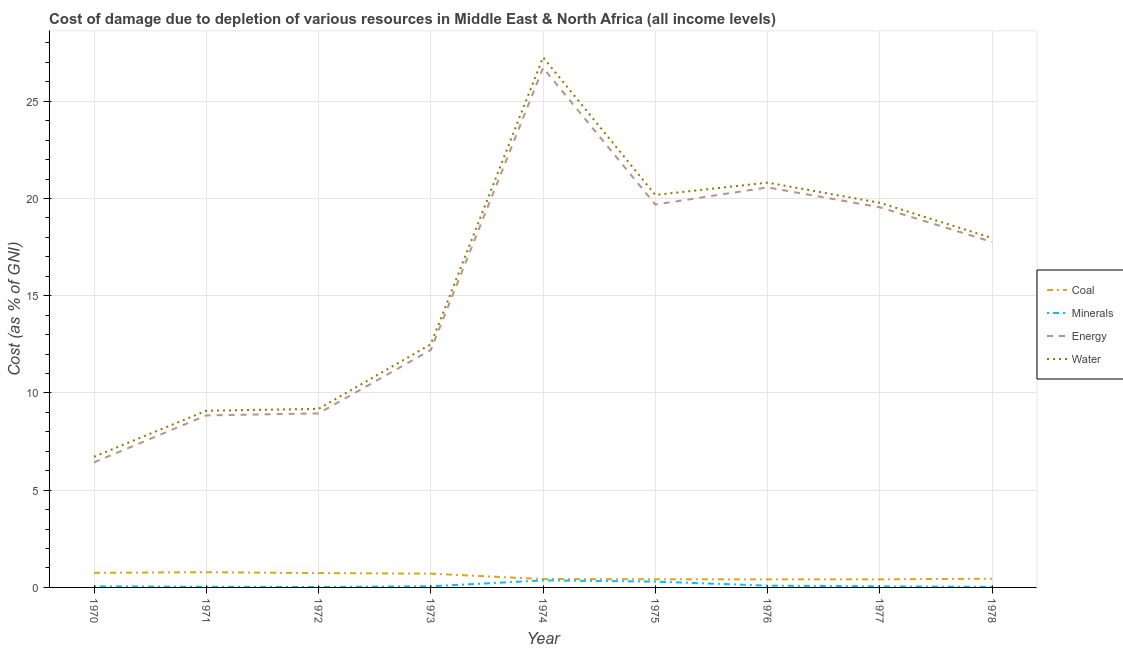Does the line corresponding to cost of damage due to depletion of energy intersect with the line corresponding to cost of damage due to depletion of water?
Make the answer very short. No. Is the number of lines equal to the number of legend labels?
Keep it short and to the point. Yes. What is the cost of damage due to depletion of water in 1973?
Offer a terse response. 12.5. Across all years, what is the maximum cost of damage due to depletion of energy?
Ensure brevity in your answer.  26.72. Across all years, what is the minimum cost of damage due to depletion of energy?
Give a very brief answer. 6.43. In which year was the cost of damage due to depletion of energy maximum?
Your answer should be very brief. 1974. What is the total cost of damage due to depletion of energy in the graph?
Make the answer very short. 140.73. What is the difference between the cost of damage due to depletion of coal in 1975 and that in 1976?
Provide a short and direct response. 0.01. What is the difference between the cost of damage due to depletion of energy in 1978 and the cost of damage due to depletion of coal in 1970?
Your answer should be compact. 17.01. What is the average cost of damage due to depletion of energy per year?
Offer a terse response. 15.64. In the year 1976, what is the difference between the cost of damage due to depletion of coal and cost of damage due to depletion of energy?
Provide a succinct answer. -20.16. In how many years, is the cost of damage due to depletion of minerals greater than 7 %?
Provide a short and direct response. 0. What is the ratio of the cost of damage due to depletion of water in 1974 to that in 1978?
Keep it short and to the point. 1.52. Is the difference between the cost of damage due to depletion of energy in 1971 and 1975 greater than the difference between the cost of damage due to depletion of minerals in 1971 and 1975?
Make the answer very short. No. What is the difference between the highest and the second highest cost of damage due to depletion of water?
Your answer should be compact. 6.45. What is the difference between the highest and the lowest cost of damage due to depletion of coal?
Provide a succinct answer. 0.37. In how many years, is the cost of damage due to depletion of minerals greater than the average cost of damage due to depletion of minerals taken over all years?
Provide a succinct answer. 2. Is it the case that in every year, the sum of the cost of damage due to depletion of coal and cost of damage due to depletion of minerals is greater than the cost of damage due to depletion of energy?
Keep it short and to the point. No. Is the cost of damage due to depletion of coal strictly greater than the cost of damage due to depletion of water over the years?
Provide a short and direct response. No. How many lines are there?
Provide a succinct answer. 4. What is the difference between two consecutive major ticks on the Y-axis?
Your answer should be very brief. 5. Are the values on the major ticks of Y-axis written in scientific E-notation?
Offer a very short reply. No. Does the graph contain any zero values?
Keep it short and to the point. No. How are the legend labels stacked?
Offer a very short reply. Vertical. What is the title of the graph?
Give a very brief answer. Cost of damage due to depletion of various resources in Middle East & North Africa (all income levels) . What is the label or title of the Y-axis?
Give a very brief answer. Cost (as % of GNI). What is the Cost (as % of GNI) in Coal in 1970?
Ensure brevity in your answer.  0.75. What is the Cost (as % of GNI) of Minerals in 1970?
Give a very brief answer. 0.05. What is the Cost (as % of GNI) of Energy in 1970?
Ensure brevity in your answer.  6.43. What is the Cost (as % of GNI) in Water in 1970?
Make the answer very short. 6.72. What is the Cost (as % of GNI) of Coal in 1971?
Make the answer very short. 0.78. What is the Cost (as % of GNI) in Minerals in 1971?
Give a very brief answer. 0.03. What is the Cost (as % of GNI) in Energy in 1971?
Ensure brevity in your answer.  8.85. What is the Cost (as % of GNI) of Water in 1971?
Your answer should be very brief. 9.09. What is the Cost (as % of GNI) in Coal in 1972?
Offer a very short reply. 0.74. What is the Cost (as % of GNI) in Minerals in 1972?
Provide a succinct answer. 0.02. What is the Cost (as % of GNI) of Energy in 1972?
Give a very brief answer. 8.95. What is the Cost (as % of GNI) in Water in 1972?
Keep it short and to the point. 9.18. What is the Cost (as % of GNI) of Coal in 1973?
Offer a very short reply. 0.71. What is the Cost (as % of GNI) in Minerals in 1973?
Provide a short and direct response. 0.06. What is the Cost (as % of GNI) of Energy in 1973?
Your answer should be very brief. 12.21. What is the Cost (as % of GNI) of Water in 1973?
Your answer should be very brief. 12.5. What is the Cost (as % of GNI) of Coal in 1974?
Provide a succinct answer. 0.43. What is the Cost (as % of GNI) of Minerals in 1974?
Offer a terse response. 0.36. What is the Cost (as % of GNI) in Energy in 1974?
Give a very brief answer. 26.72. What is the Cost (as % of GNI) in Water in 1974?
Make the answer very short. 27.26. What is the Cost (as % of GNI) in Coal in 1975?
Offer a terse response. 0.42. What is the Cost (as % of GNI) of Minerals in 1975?
Offer a very short reply. 0.3. What is the Cost (as % of GNI) in Energy in 1975?
Your response must be concise. 19.69. What is the Cost (as % of GNI) of Water in 1975?
Make the answer very short. 20.18. What is the Cost (as % of GNI) of Coal in 1976?
Ensure brevity in your answer.  0.41. What is the Cost (as % of GNI) in Minerals in 1976?
Your response must be concise. 0.09. What is the Cost (as % of GNI) in Energy in 1976?
Your answer should be very brief. 20.57. What is the Cost (as % of GNI) of Water in 1976?
Ensure brevity in your answer.  20.81. What is the Cost (as % of GNI) of Coal in 1977?
Your answer should be very brief. 0.42. What is the Cost (as % of GNI) in Minerals in 1977?
Give a very brief answer. 0.05. What is the Cost (as % of GNI) of Energy in 1977?
Offer a very short reply. 19.55. What is the Cost (as % of GNI) in Water in 1977?
Your response must be concise. 19.78. What is the Cost (as % of GNI) of Coal in 1978?
Make the answer very short. 0.45. What is the Cost (as % of GNI) in Minerals in 1978?
Give a very brief answer. 0.03. What is the Cost (as % of GNI) of Energy in 1978?
Your answer should be very brief. 17.77. What is the Cost (as % of GNI) of Water in 1978?
Give a very brief answer. 17.96. Across all years, what is the maximum Cost (as % of GNI) in Coal?
Offer a terse response. 0.78. Across all years, what is the maximum Cost (as % of GNI) in Minerals?
Your answer should be compact. 0.36. Across all years, what is the maximum Cost (as % of GNI) in Energy?
Offer a very short reply. 26.72. Across all years, what is the maximum Cost (as % of GNI) of Water?
Your answer should be compact. 27.26. Across all years, what is the minimum Cost (as % of GNI) in Coal?
Ensure brevity in your answer.  0.41. Across all years, what is the minimum Cost (as % of GNI) in Minerals?
Keep it short and to the point. 0.02. Across all years, what is the minimum Cost (as % of GNI) in Energy?
Provide a succinct answer. 6.43. Across all years, what is the minimum Cost (as % of GNI) in Water?
Offer a terse response. 6.72. What is the total Cost (as % of GNI) of Coal in the graph?
Ensure brevity in your answer.  5.11. What is the total Cost (as % of GNI) of Minerals in the graph?
Provide a short and direct response. 1.01. What is the total Cost (as % of GNI) in Energy in the graph?
Your response must be concise. 140.73. What is the total Cost (as % of GNI) of Water in the graph?
Give a very brief answer. 143.49. What is the difference between the Cost (as % of GNI) in Coal in 1970 and that in 1971?
Provide a succinct answer. -0.03. What is the difference between the Cost (as % of GNI) in Minerals in 1970 and that in 1971?
Keep it short and to the point. 0.02. What is the difference between the Cost (as % of GNI) of Energy in 1970 and that in 1971?
Your answer should be very brief. -2.41. What is the difference between the Cost (as % of GNI) in Water in 1970 and that in 1971?
Provide a short and direct response. -2.37. What is the difference between the Cost (as % of GNI) of Coal in 1970 and that in 1972?
Make the answer very short. 0.01. What is the difference between the Cost (as % of GNI) of Minerals in 1970 and that in 1972?
Keep it short and to the point. 0.03. What is the difference between the Cost (as % of GNI) of Energy in 1970 and that in 1972?
Ensure brevity in your answer.  -2.52. What is the difference between the Cost (as % of GNI) in Water in 1970 and that in 1972?
Make the answer very short. -2.46. What is the difference between the Cost (as % of GNI) in Coal in 1970 and that in 1973?
Your answer should be compact. 0.04. What is the difference between the Cost (as % of GNI) in Minerals in 1970 and that in 1973?
Give a very brief answer. -0. What is the difference between the Cost (as % of GNI) in Energy in 1970 and that in 1973?
Make the answer very short. -5.78. What is the difference between the Cost (as % of GNI) of Water in 1970 and that in 1973?
Offer a very short reply. -5.78. What is the difference between the Cost (as % of GNI) in Coal in 1970 and that in 1974?
Offer a very short reply. 0.32. What is the difference between the Cost (as % of GNI) in Minerals in 1970 and that in 1974?
Give a very brief answer. -0.31. What is the difference between the Cost (as % of GNI) of Energy in 1970 and that in 1974?
Provide a short and direct response. -20.29. What is the difference between the Cost (as % of GNI) of Water in 1970 and that in 1974?
Make the answer very short. -20.54. What is the difference between the Cost (as % of GNI) of Coal in 1970 and that in 1975?
Provide a short and direct response. 0.33. What is the difference between the Cost (as % of GNI) of Minerals in 1970 and that in 1975?
Your answer should be very brief. -0.24. What is the difference between the Cost (as % of GNI) of Energy in 1970 and that in 1975?
Provide a succinct answer. -13.26. What is the difference between the Cost (as % of GNI) in Water in 1970 and that in 1975?
Give a very brief answer. -13.46. What is the difference between the Cost (as % of GNI) in Coal in 1970 and that in 1976?
Your response must be concise. 0.34. What is the difference between the Cost (as % of GNI) in Minerals in 1970 and that in 1976?
Your response must be concise. -0.04. What is the difference between the Cost (as % of GNI) of Energy in 1970 and that in 1976?
Your answer should be compact. -14.14. What is the difference between the Cost (as % of GNI) of Water in 1970 and that in 1976?
Provide a short and direct response. -14.09. What is the difference between the Cost (as % of GNI) in Coal in 1970 and that in 1977?
Give a very brief answer. 0.34. What is the difference between the Cost (as % of GNI) of Minerals in 1970 and that in 1977?
Your response must be concise. -0. What is the difference between the Cost (as % of GNI) in Energy in 1970 and that in 1977?
Your response must be concise. -13.12. What is the difference between the Cost (as % of GNI) in Water in 1970 and that in 1977?
Your answer should be very brief. -13.06. What is the difference between the Cost (as % of GNI) in Coal in 1970 and that in 1978?
Make the answer very short. 0.3. What is the difference between the Cost (as % of GNI) of Minerals in 1970 and that in 1978?
Your response must be concise. 0.03. What is the difference between the Cost (as % of GNI) of Energy in 1970 and that in 1978?
Offer a terse response. -11.33. What is the difference between the Cost (as % of GNI) of Water in 1970 and that in 1978?
Your response must be concise. -11.24. What is the difference between the Cost (as % of GNI) in Coal in 1971 and that in 1972?
Your answer should be very brief. 0.04. What is the difference between the Cost (as % of GNI) of Minerals in 1971 and that in 1972?
Provide a short and direct response. 0.01. What is the difference between the Cost (as % of GNI) in Energy in 1971 and that in 1972?
Make the answer very short. -0.1. What is the difference between the Cost (as % of GNI) in Water in 1971 and that in 1972?
Provide a short and direct response. -0.1. What is the difference between the Cost (as % of GNI) of Coal in 1971 and that in 1973?
Offer a terse response. 0.07. What is the difference between the Cost (as % of GNI) in Minerals in 1971 and that in 1973?
Provide a short and direct response. -0.02. What is the difference between the Cost (as % of GNI) of Energy in 1971 and that in 1973?
Make the answer very short. -3.36. What is the difference between the Cost (as % of GNI) of Water in 1971 and that in 1973?
Provide a succinct answer. -3.42. What is the difference between the Cost (as % of GNI) in Coal in 1971 and that in 1974?
Your answer should be very brief. 0.35. What is the difference between the Cost (as % of GNI) in Minerals in 1971 and that in 1974?
Give a very brief answer. -0.33. What is the difference between the Cost (as % of GNI) in Energy in 1971 and that in 1974?
Your response must be concise. -17.87. What is the difference between the Cost (as % of GNI) of Water in 1971 and that in 1974?
Provide a short and direct response. -18.17. What is the difference between the Cost (as % of GNI) in Coal in 1971 and that in 1975?
Ensure brevity in your answer.  0.36. What is the difference between the Cost (as % of GNI) of Minerals in 1971 and that in 1975?
Your answer should be very brief. -0.27. What is the difference between the Cost (as % of GNI) in Energy in 1971 and that in 1975?
Provide a short and direct response. -10.84. What is the difference between the Cost (as % of GNI) of Water in 1971 and that in 1975?
Offer a very short reply. -11.1. What is the difference between the Cost (as % of GNI) in Coal in 1971 and that in 1976?
Offer a terse response. 0.37. What is the difference between the Cost (as % of GNI) in Minerals in 1971 and that in 1976?
Provide a succinct answer. -0.06. What is the difference between the Cost (as % of GNI) of Energy in 1971 and that in 1976?
Ensure brevity in your answer.  -11.72. What is the difference between the Cost (as % of GNI) of Water in 1971 and that in 1976?
Your response must be concise. -11.73. What is the difference between the Cost (as % of GNI) of Coal in 1971 and that in 1977?
Give a very brief answer. 0.37. What is the difference between the Cost (as % of GNI) in Minerals in 1971 and that in 1977?
Offer a very short reply. -0.02. What is the difference between the Cost (as % of GNI) of Energy in 1971 and that in 1977?
Make the answer very short. -10.7. What is the difference between the Cost (as % of GNI) in Water in 1971 and that in 1977?
Ensure brevity in your answer.  -10.69. What is the difference between the Cost (as % of GNI) in Coal in 1971 and that in 1978?
Provide a short and direct response. 0.33. What is the difference between the Cost (as % of GNI) of Minerals in 1971 and that in 1978?
Offer a very short reply. 0. What is the difference between the Cost (as % of GNI) in Energy in 1971 and that in 1978?
Make the answer very short. -8.92. What is the difference between the Cost (as % of GNI) of Water in 1971 and that in 1978?
Offer a very short reply. -8.88. What is the difference between the Cost (as % of GNI) in Coal in 1972 and that in 1973?
Make the answer very short. 0.03. What is the difference between the Cost (as % of GNI) of Minerals in 1972 and that in 1973?
Your answer should be compact. -0.03. What is the difference between the Cost (as % of GNI) of Energy in 1972 and that in 1973?
Provide a short and direct response. -3.26. What is the difference between the Cost (as % of GNI) in Water in 1972 and that in 1973?
Offer a very short reply. -3.32. What is the difference between the Cost (as % of GNI) in Coal in 1972 and that in 1974?
Give a very brief answer. 0.31. What is the difference between the Cost (as % of GNI) in Minerals in 1972 and that in 1974?
Ensure brevity in your answer.  -0.34. What is the difference between the Cost (as % of GNI) in Energy in 1972 and that in 1974?
Keep it short and to the point. -17.77. What is the difference between the Cost (as % of GNI) in Water in 1972 and that in 1974?
Your answer should be very brief. -18.08. What is the difference between the Cost (as % of GNI) in Coal in 1972 and that in 1975?
Your response must be concise. 0.32. What is the difference between the Cost (as % of GNI) of Minerals in 1972 and that in 1975?
Provide a short and direct response. -0.27. What is the difference between the Cost (as % of GNI) in Energy in 1972 and that in 1975?
Ensure brevity in your answer.  -10.74. What is the difference between the Cost (as % of GNI) in Water in 1972 and that in 1975?
Your response must be concise. -11. What is the difference between the Cost (as % of GNI) in Coal in 1972 and that in 1976?
Ensure brevity in your answer.  0.33. What is the difference between the Cost (as % of GNI) in Minerals in 1972 and that in 1976?
Provide a succinct answer. -0.07. What is the difference between the Cost (as % of GNI) in Energy in 1972 and that in 1976?
Offer a terse response. -11.62. What is the difference between the Cost (as % of GNI) of Water in 1972 and that in 1976?
Keep it short and to the point. -11.63. What is the difference between the Cost (as % of GNI) of Coal in 1972 and that in 1977?
Ensure brevity in your answer.  0.32. What is the difference between the Cost (as % of GNI) of Minerals in 1972 and that in 1977?
Provide a short and direct response. -0.03. What is the difference between the Cost (as % of GNI) in Energy in 1972 and that in 1977?
Offer a very short reply. -10.6. What is the difference between the Cost (as % of GNI) of Water in 1972 and that in 1977?
Your answer should be very brief. -10.6. What is the difference between the Cost (as % of GNI) in Coal in 1972 and that in 1978?
Keep it short and to the point. 0.29. What is the difference between the Cost (as % of GNI) of Minerals in 1972 and that in 1978?
Your answer should be compact. -0.01. What is the difference between the Cost (as % of GNI) of Energy in 1972 and that in 1978?
Ensure brevity in your answer.  -8.82. What is the difference between the Cost (as % of GNI) in Water in 1972 and that in 1978?
Provide a succinct answer. -8.78. What is the difference between the Cost (as % of GNI) of Coal in 1973 and that in 1974?
Offer a very short reply. 0.28. What is the difference between the Cost (as % of GNI) of Minerals in 1973 and that in 1974?
Provide a short and direct response. -0.3. What is the difference between the Cost (as % of GNI) in Energy in 1973 and that in 1974?
Provide a succinct answer. -14.51. What is the difference between the Cost (as % of GNI) of Water in 1973 and that in 1974?
Make the answer very short. -14.76. What is the difference between the Cost (as % of GNI) in Coal in 1973 and that in 1975?
Provide a short and direct response. 0.29. What is the difference between the Cost (as % of GNI) in Minerals in 1973 and that in 1975?
Your response must be concise. -0.24. What is the difference between the Cost (as % of GNI) of Energy in 1973 and that in 1975?
Give a very brief answer. -7.48. What is the difference between the Cost (as % of GNI) of Water in 1973 and that in 1975?
Your answer should be compact. -7.68. What is the difference between the Cost (as % of GNI) of Coal in 1973 and that in 1976?
Ensure brevity in your answer.  0.29. What is the difference between the Cost (as % of GNI) in Minerals in 1973 and that in 1976?
Provide a succinct answer. -0.03. What is the difference between the Cost (as % of GNI) in Energy in 1973 and that in 1976?
Ensure brevity in your answer.  -8.36. What is the difference between the Cost (as % of GNI) in Water in 1973 and that in 1976?
Provide a short and direct response. -8.31. What is the difference between the Cost (as % of GNI) of Coal in 1973 and that in 1977?
Ensure brevity in your answer.  0.29. What is the difference between the Cost (as % of GNI) in Minerals in 1973 and that in 1977?
Keep it short and to the point. 0. What is the difference between the Cost (as % of GNI) of Energy in 1973 and that in 1977?
Offer a very short reply. -7.34. What is the difference between the Cost (as % of GNI) in Water in 1973 and that in 1977?
Offer a very short reply. -7.27. What is the difference between the Cost (as % of GNI) in Coal in 1973 and that in 1978?
Give a very brief answer. 0.26. What is the difference between the Cost (as % of GNI) in Minerals in 1973 and that in 1978?
Offer a terse response. 0.03. What is the difference between the Cost (as % of GNI) of Energy in 1973 and that in 1978?
Offer a very short reply. -5.56. What is the difference between the Cost (as % of GNI) of Water in 1973 and that in 1978?
Your response must be concise. -5.46. What is the difference between the Cost (as % of GNI) of Coal in 1974 and that in 1975?
Give a very brief answer. 0.01. What is the difference between the Cost (as % of GNI) in Minerals in 1974 and that in 1975?
Your answer should be very brief. 0.06. What is the difference between the Cost (as % of GNI) in Energy in 1974 and that in 1975?
Your answer should be compact. 7.03. What is the difference between the Cost (as % of GNI) in Water in 1974 and that in 1975?
Ensure brevity in your answer.  7.08. What is the difference between the Cost (as % of GNI) in Coal in 1974 and that in 1976?
Your answer should be very brief. 0.02. What is the difference between the Cost (as % of GNI) in Minerals in 1974 and that in 1976?
Offer a terse response. 0.27. What is the difference between the Cost (as % of GNI) in Energy in 1974 and that in 1976?
Keep it short and to the point. 6.15. What is the difference between the Cost (as % of GNI) in Water in 1974 and that in 1976?
Your answer should be compact. 6.45. What is the difference between the Cost (as % of GNI) in Coal in 1974 and that in 1977?
Give a very brief answer. 0.01. What is the difference between the Cost (as % of GNI) in Minerals in 1974 and that in 1977?
Provide a short and direct response. 0.31. What is the difference between the Cost (as % of GNI) in Energy in 1974 and that in 1977?
Your answer should be very brief. 7.17. What is the difference between the Cost (as % of GNI) of Water in 1974 and that in 1977?
Your answer should be very brief. 7.48. What is the difference between the Cost (as % of GNI) in Coal in 1974 and that in 1978?
Your answer should be compact. -0.02. What is the difference between the Cost (as % of GNI) of Minerals in 1974 and that in 1978?
Your answer should be compact. 0.33. What is the difference between the Cost (as % of GNI) of Energy in 1974 and that in 1978?
Keep it short and to the point. 8.95. What is the difference between the Cost (as % of GNI) of Water in 1974 and that in 1978?
Your answer should be very brief. 9.29. What is the difference between the Cost (as % of GNI) of Coal in 1975 and that in 1976?
Keep it short and to the point. 0.01. What is the difference between the Cost (as % of GNI) in Minerals in 1975 and that in 1976?
Provide a succinct answer. 0.21. What is the difference between the Cost (as % of GNI) in Energy in 1975 and that in 1976?
Offer a terse response. -0.88. What is the difference between the Cost (as % of GNI) of Water in 1975 and that in 1976?
Ensure brevity in your answer.  -0.63. What is the difference between the Cost (as % of GNI) in Coal in 1975 and that in 1977?
Make the answer very short. 0. What is the difference between the Cost (as % of GNI) in Minerals in 1975 and that in 1977?
Your answer should be very brief. 0.24. What is the difference between the Cost (as % of GNI) of Energy in 1975 and that in 1977?
Provide a succinct answer. 0.14. What is the difference between the Cost (as % of GNI) in Water in 1975 and that in 1977?
Your answer should be compact. 0.4. What is the difference between the Cost (as % of GNI) of Coal in 1975 and that in 1978?
Offer a terse response. -0.03. What is the difference between the Cost (as % of GNI) in Minerals in 1975 and that in 1978?
Ensure brevity in your answer.  0.27. What is the difference between the Cost (as % of GNI) in Energy in 1975 and that in 1978?
Your answer should be compact. 1.92. What is the difference between the Cost (as % of GNI) of Water in 1975 and that in 1978?
Provide a short and direct response. 2.22. What is the difference between the Cost (as % of GNI) of Coal in 1976 and that in 1977?
Ensure brevity in your answer.  -0. What is the difference between the Cost (as % of GNI) in Minerals in 1976 and that in 1977?
Offer a terse response. 0.04. What is the difference between the Cost (as % of GNI) in Energy in 1976 and that in 1977?
Keep it short and to the point. 1.02. What is the difference between the Cost (as % of GNI) of Water in 1976 and that in 1977?
Offer a terse response. 1.04. What is the difference between the Cost (as % of GNI) of Coal in 1976 and that in 1978?
Make the answer very short. -0.03. What is the difference between the Cost (as % of GNI) of Minerals in 1976 and that in 1978?
Keep it short and to the point. 0.06. What is the difference between the Cost (as % of GNI) of Energy in 1976 and that in 1978?
Your answer should be very brief. 2.8. What is the difference between the Cost (as % of GNI) of Water in 1976 and that in 1978?
Provide a succinct answer. 2.85. What is the difference between the Cost (as % of GNI) of Coal in 1977 and that in 1978?
Give a very brief answer. -0.03. What is the difference between the Cost (as % of GNI) in Minerals in 1977 and that in 1978?
Your response must be concise. 0.03. What is the difference between the Cost (as % of GNI) of Energy in 1977 and that in 1978?
Your answer should be very brief. 1.78. What is the difference between the Cost (as % of GNI) in Water in 1977 and that in 1978?
Your answer should be compact. 1.81. What is the difference between the Cost (as % of GNI) of Coal in 1970 and the Cost (as % of GNI) of Minerals in 1971?
Your response must be concise. 0.72. What is the difference between the Cost (as % of GNI) in Coal in 1970 and the Cost (as % of GNI) in Energy in 1971?
Your response must be concise. -8.09. What is the difference between the Cost (as % of GNI) of Coal in 1970 and the Cost (as % of GNI) of Water in 1971?
Provide a short and direct response. -8.33. What is the difference between the Cost (as % of GNI) of Minerals in 1970 and the Cost (as % of GNI) of Energy in 1971?
Give a very brief answer. -8.79. What is the difference between the Cost (as % of GNI) in Minerals in 1970 and the Cost (as % of GNI) in Water in 1971?
Your answer should be compact. -9.03. What is the difference between the Cost (as % of GNI) of Energy in 1970 and the Cost (as % of GNI) of Water in 1971?
Keep it short and to the point. -2.65. What is the difference between the Cost (as % of GNI) in Coal in 1970 and the Cost (as % of GNI) in Minerals in 1972?
Keep it short and to the point. 0.73. What is the difference between the Cost (as % of GNI) of Coal in 1970 and the Cost (as % of GNI) of Energy in 1972?
Ensure brevity in your answer.  -8.2. What is the difference between the Cost (as % of GNI) of Coal in 1970 and the Cost (as % of GNI) of Water in 1972?
Your answer should be compact. -8.43. What is the difference between the Cost (as % of GNI) in Minerals in 1970 and the Cost (as % of GNI) in Energy in 1972?
Provide a short and direct response. -8.89. What is the difference between the Cost (as % of GNI) of Minerals in 1970 and the Cost (as % of GNI) of Water in 1972?
Offer a terse response. -9.13. What is the difference between the Cost (as % of GNI) in Energy in 1970 and the Cost (as % of GNI) in Water in 1972?
Offer a terse response. -2.75. What is the difference between the Cost (as % of GNI) in Coal in 1970 and the Cost (as % of GNI) in Minerals in 1973?
Ensure brevity in your answer.  0.69. What is the difference between the Cost (as % of GNI) in Coal in 1970 and the Cost (as % of GNI) in Energy in 1973?
Your answer should be compact. -11.46. What is the difference between the Cost (as % of GNI) of Coal in 1970 and the Cost (as % of GNI) of Water in 1973?
Provide a short and direct response. -11.75. What is the difference between the Cost (as % of GNI) of Minerals in 1970 and the Cost (as % of GNI) of Energy in 1973?
Your answer should be compact. -12.16. What is the difference between the Cost (as % of GNI) in Minerals in 1970 and the Cost (as % of GNI) in Water in 1973?
Make the answer very short. -12.45. What is the difference between the Cost (as % of GNI) in Energy in 1970 and the Cost (as % of GNI) in Water in 1973?
Provide a short and direct response. -6.07. What is the difference between the Cost (as % of GNI) in Coal in 1970 and the Cost (as % of GNI) in Minerals in 1974?
Keep it short and to the point. 0.39. What is the difference between the Cost (as % of GNI) of Coal in 1970 and the Cost (as % of GNI) of Energy in 1974?
Your response must be concise. -25.97. What is the difference between the Cost (as % of GNI) in Coal in 1970 and the Cost (as % of GNI) in Water in 1974?
Your response must be concise. -26.51. What is the difference between the Cost (as % of GNI) of Minerals in 1970 and the Cost (as % of GNI) of Energy in 1974?
Make the answer very short. -26.67. What is the difference between the Cost (as % of GNI) of Minerals in 1970 and the Cost (as % of GNI) of Water in 1974?
Your response must be concise. -27.2. What is the difference between the Cost (as % of GNI) in Energy in 1970 and the Cost (as % of GNI) in Water in 1974?
Make the answer very short. -20.83. What is the difference between the Cost (as % of GNI) in Coal in 1970 and the Cost (as % of GNI) in Minerals in 1975?
Provide a succinct answer. 0.45. What is the difference between the Cost (as % of GNI) of Coal in 1970 and the Cost (as % of GNI) of Energy in 1975?
Your answer should be compact. -18.94. What is the difference between the Cost (as % of GNI) in Coal in 1970 and the Cost (as % of GNI) in Water in 1975?
Your response must be concise. -19.43. What is the difference between the Cost (as % of GNI) in Minerals in 1970 and the Cost (as % of GNI) in Energy in 1975?
Your answer should be compact. -19.63. What is the difference between the Cost (as % of GNI) in Minerals in 1970 and the Cost (as % of GNI) in Water in 1975?
Your answer should be compact. -20.13. What is the difference between the Cost (as % of GNI) in Energy in 1970 and the Cost (as % of GNI) in Water in 1975?
Make the answer very short. -13.75. What is the difference between the Cost (as % of GNI) in Coal in 1970 and the Cost (as % of GNI) in Minerals in 1976?
Make the answer very short. 0.66. What is the difference between the Cost (as % of GNI) of Coal in 1970 and the Cost (as % of GNI) of Energy in 1976?
Make the answer very short. -19.82. What is the difference between the Cost (as % of GNI) of Coal in 1970 and the Cost (as % of GNI) of Water in 1976?
Ensure brevity in your answer.  -20.06. What is the difference between the Cost (as % of GNI) of Minerals in 1970 and the Cost (as % of GNI) of Energy in 1976?
Ensure brevity in your answer.  -20.52. What is the difference between the Cost (as % of GNI) in Minerals in 1970 and the Cost (as % of GNI) in Water in 1976?
Keep it short and to the point. -20.76. What is the difference between the Cost (as % of GNI) in Energy in 1970 and the Cost (as % of GNI) in Water in 1976?
Offer a terse response. -14.38. What is the difference between the Cost (as % of GNI) of Coal in 1970 and the Cost (as % of GNI) of Minerals in 1977?
Keep it short and to the point. 0.7. What is the difference between the Cost (as % of GNI) of Coal in 1970 and the Cost (as % of GNI) of Energy in 1977?
Provide a short and direct response. -18.8. What is the difference between the Cost (as % of GNI) in Coal in 1970 and the Cost (as % of GNI) in Water in 1977?
Your response must be concise. -19.03. What is the difference between the Cost (as % of GNI) in Minerals in 1970 and the Cost (as % of GNI) in Energy in 1977?
Your answer should be very brief. -19.49. What is the difference between the Cost (as % of GNI) in Minerals in 1970 and the Cost (as % of GNI) in Water in 1977?
Provide a short and direct response. -19.72. What is the difference between the Cost (as % of GNI) of Energy in 1970 and the Cost (as % of GNI) of Water in 1977?
Provide a succinct answer. -13.35. What is the difference between the Cost (as % of GNI) of Coal in 1970 and the Cost (as % of GNI) of Minerals in 1978?
Provide a succinct answer. 0.72. What is the difference between the Cost (as % of GNI) of Coal in 1970 and the Cost (as % of GNI) of Energy in 1978?
Your answer should be compact. -17.01. What is the difference between the Cost (as % of GNI) of Coal in 1970 and the Cost (as % of GNI) of Water in 1978?
Keep it short and to the point. -17.21. What is the difference between the Cost (as % of GNI) of Minerals in 1970 and the Cost (as % of GNI) of Energy in 1978?
Give a very brief answer. -17.71. What is the difference between the Cost (as % of GNI) in Minerals in 1970 and the Cost (as % of GNI) in Water in 1978?
Your response must be concise. -17.91. What is the difference between the Cost (as % of GNI) of Energy in 1970 and the Cost (as % of GNI) of Water in 1978?
Offer a very short reply. -11.53. What is the difference between the Cost (as % of GNI) of Coal in 1971 and the Cost (as % of GNI) of Minerals in 1972?
Offer a very short reply. 0.76. What is the difference between the Cost (as % of GNI) in Coal in 1971 and the Cost (as % of GNI) in Energy in 1972?
Provide a succinct answer. -8.17. What is the difference between the Cost (as % of GNI) of Minerals in 1971 and the Cost (as % of GNI) of Energy in 1972?
Your answer should be compact. -8.92. What is the difference between the Cost (as % of GNI) of Minerals in 1971 and the Cost (as % of GNI) of Water in 1972?
Your answer should be very brief. -9.15. What is the difference between the Cost (as % of GNI) in Energy in 1971 and the Cost (as % of GNI) in Water in 1972?
Provide a succinct answer. -0.34. What is the difference between the Cost (as % of GNI) in Coal in 1971 and the Cost (as % of GNI) in Minerals in 1973?
Offer a very short reply. 0.72. What is the difference between the Cost (as % of GNI) in Coal in 1971 and the Cost (as % of GNI) in Energy in 1973?
Your answer should be compact. -11.43. What is the difference between the Cost (as % of GNI) of Coal in 1971 and the Cost (as % of GNI) of Water in 1973?
Make the answer very short. -11.72. What is the difference between the Cost (as % of GNI) of Minerals in 1971 and the Cost (as % of GNI) of Energy in 1973?
Keep it short and to the point. -12.18. What is the difference between the Cost (as % of GNI) in Minerals in 1971 and the Cost (as % of GNI) in Water in 1973?
Offer a very short reply. -12.47. What is the difference between the Cost (as % of GNI) in Energy in 1971 and the Cost (as % of GNI) in Water in 1973?
Provide a succinct answer. -3.66. What is the difference between the Cost (as % of GNI) in Coal in 1971 and the Cost (as % of GNI) in Minerals in 1974?
Ensure brevity in your answer.  0.42. What is the difference between the Cost (as % of GNI) in Coal in 1971 and the Cost (as % of GNI) in Energy in 1974?
Your answer should be very brief. -25.94. What is the difference between the Cost (as % of GNI) of Coal in 1971 and the Cost (as % of GNI) of Water in 1974?
Keep it short and to the point. -26.48. What is the difference between the Cost (as % of GNI) of Minerals in 1971 and the Cost (as % of GNI) of Energy in 1974?
Provide a succinct answer. -26.69. What is the difference between the Cost (as % of GNI) in Minerals in 1971 and the Cost (as % of GNI) in Water in 1974?
Offer a very short reply. -27.23. What is the difference between the Cost (as % of GNI) in Energy in 1971 and the Cost (as % of GNI) in Water in 1974?
Give a very brief answer. -18.41. What is the difference between the Cost (as % of GNI) in Coal in 1971 and the Cost (as % of GNI) in Minerals in 1975?
Offer a very short reply. 0.48. What is the difference between the Cost (as % of GNI) in Coal in 1971 and the Cost (as % of GNI) in Energy in 1975?
Offer a very short reply. -18.91. What is the difference between the Cost (as % of GNI) in Coal in 1971 and the Cost (as % of GNI) in Water in 1975?
Provide a short and direct response. -19.4. What is the difference between the Cost (as % of GNI) of Minerals in 1971 and the Cost (as % of GNI) of Energy in 1975?
Offer a very short reply. -19.65. What is the difference between the Cost (as % of GNI) of Minerals in 1971 and the Cost (as % of GNI) of Water in 1975?
Offer a very short reply. -20.15. What is the difference between the Cost (as % of GNI) in Energy in 1971 and the Cost (as % of GNI) in Water in 1975?
Your answer should be very brief. -11.34. What is the difference between the Cost (as % of GNI) in Coal in 1971 and the Cost (as % of GNI) in Minerals in 1976?
Provide a short and direct response. 0.69. What is the difference between the Cost (as % of GNI) of Coal in 1971 and the Cost (as % of GNI) of Energy in 1976?
Provide a succinct answer. -19.79. What is the difference between the Cost (as % of GNI) of Coal in 1971 and the Cost (as % of GNI) of Water in 1976?
Your response must be concise. -20.03. What is the difference between the Cost (as % of GNI) of Minerals in 1971 and the Cost (as % of GNI) of Energy in 1976?
Make the answer very short. -20.54. What is the difference between the Cost (as % of GNI) of Minerals in 1971 and the Cost (as % of GNI) of Water in 1976?
Offer a very short reply. -20.78. What is the difference between the Cost (as % of GNI) in Energy in 1971 and the Cost (as % of GNI) in Water in 1976?
Give a very brief answer. -11.97. What is the difference between the Cost (as % of GNI) in Coal in 1971 and the Cost (as % of GNI) in Minerals in 1977?
Offer a very short reply. 0.73. What is the difference between the Cost (as % of GNI) in Coal in 1971 and the Cost (as % of GNI) in Energy in 1977?
Offer a very short reply. -18.77. What is the difference between the Cost (as % of GNI) of Coal in 1971 and the Cost (as % of GNI) of Water in 1977?
Give a very brief answer. -19. What is the difference between the Cost (as % of GNI) of Minerals in 1971 and the Cost (as % of GNI) of Energy in 1977?
Your response must be concise. -19.51. What is the difference between the Cost (as % of GNI) of Minerals in 1971 and the Cost (as % of GNI) of Water in 1977?
Your answer should be very brief. -19.74. What is the difference between the Cost (as % of GNI) of Energy in 1971 and the Cost (as % of GNI) of Water in 1977?
Provide a succinct answer. -10.93. What is the difference between the Cost (as % of GNI) in Coal in 1971 and the Cost (as % of GNI) in Minerals in 1978?
Ensure brevity in your answer.  0.75. What is the difference between the Cost (as % of GNI) of Coal in 1971 and the Cost (as % of GNI) of Energy in 1978?
Your response must be concise. -16.98. What is the difference between the Cost (as % of GNI) in Coal in 1971 and the Cost (as % of GNI) in Water in 1978?
Your answer should be very brief. -17.18. What is the difference between the Cost (as % of GNI) of Minerals in 1971 and the Cost (as % of GNI) of Energy in 1978?
Provide a short and direct response. -17.73. What is the difference between the Cost (as % of GNI) of Minerals in 1971 and the Cost (as % of GNI) of Water in 1978?
Your answer should be compact. -17.93. What is the difference between the Cost (as % of GNI) in Energy in 1971 and the Cost (as % of GNI) in Water in 1978?
Offer a very short reply. -9.12. What is the difference between the Cost (as % of GNI) of Coal in 1972 and the Cost (as % of GNI) of Minerals in 1973?
Ensure brevity in your answer.  0.68. What is the difference between the Cost (as % of GNI) in Coal in 1972 and the Cost (as % of GNI) in Energy in 1973?
Offer a very short reply. -11.47. What is the difference between the Cost (as % of GNI) of Coal in 1972 and the Cost (as % of GNI) of Water in 1973?
Provide a succinct answer. -11.77. What is the difference between the Cost (as % of GNI) in Minerals in 1972 and the Cost (as % of GNI) in Energy in 1973?
Keep it short and to the point. -12.19. What is the difference between the Cost (as % of GNI) of Minerals in 1972 and the Cost (as % of GNI) of Water in 1973?
Provide a succinct answer. -12.48. What is the difference between the Cost (as % of GNI) in Energy in 1972 and the Cost (as % of GNI) in Water in 1973?
Your response must be concise. -3.56. What is the difference between the Cost (as % of GNI) in Coal in 1972 and the Cost (as % of GNI) in Minerals in 1974?
Your answer should be very brief. 0.38. What is the difference between the Cost (as % of GNI) in Coal in 1972 and the Cost (as % of GNI) in Energy in 1974?
Keep it short and to the point. -25.98. What is the difference between the Cost (as % of GNI) in Coal in 1972 and the Cost (as % of GNI) in Water in 1974?
Give a very brief answer. -26.52. What is the difference between the Cost (as % of GNI) of Minerals in 1972 and the Cost (as % of GNI) of Energy in 1974?
Make the answer very short. -26.7. What is the difference between the Cost (as % of GNI) of Minerals in 1972 and the Cost (as % of GNI) of Water in 1974?
Your answer should be very brief. -27.24. What is the difference between the Cost (as % of GNI) of Energy in 1972 and the Cost (as % of GNI) of Water in 1974?
Provide a short and direct response. -18.31. What is the difference between the Cost (as % of GNI) in Coal in 1972 and the Cost (as % of GNI) in Minerals in 1975?
Provide a short and direct response. 0.44. What is the difference between the Cost (as % of GNI) of Coal in 1972 and the Cost (as % of GNI) of Energy in 1975?
Make the answer very short. -18.95. What is the difference between the Cost (as % of GNI) in Coal in 1972 and the Cost (as % of GNI) in Water in 1975?
Your response must be concise. -19.44. What is the difference between the Cost (as % of GNI) of Minerals in 1972 and the Cost (as % of GNI) of Energy in 1975?
Your answer should be very brief. -19.66. What is the difference between the Cost (as % of GNI) in Minerals in 1972 and the Cost (as % of GNI) in Water in 1975?
Your answer should be compact. -20.16. What is the difference between the Cost (as % of GNI) in Energy in 1972 and the Cost (as % of GNI) in Water in 1975?
Provide a short and direct response. -11.23. What is the difference between the Cost (as % of GNI) in Coal in 1972 and the Cost (as % of GNI) in Minerals in 1976?
Your answer should be compact. 0.65. What is the difference between the Cost (as % of GNI) of Coal in 1972 and the Cost (as % of GNI) of Energy in 1976?
Provide a short and direct response. -19.83. What is the difference between the Cost (as % of GNI) of Coal in 1972 and the Cost (as % of GNI) of Water in 1976?
Make the answer very short. -20.08. What is the difference between the Cost (as % of GNI) of Minerals in 1972 and the Cost (as % of GNI) of Energy in 1976?
Your answer should be compact. -20.55. What is the difference between the Cost (as % of GNI) of Minerals in 1972 and the Cost (as % of GNI) of Water in 1976?
Keep it short and to the point. -20.79. What is the difference between the Cost (as % of GNI) in Energy in 1972 and the Cost (as % of GNI) in Water in 1976?
Make the answer very short. -11.87. What is the difference between the Cost (as % of GNI) in Coal in 1972 and the Cost (as % of GNI) in Minerals in 1977?
Give a very brief answer. 0.68. What is the difference between the Cost (as % of GNI) of Coal in 1972 and the Cost (as % of GNI) of Energy in 1977?
Give a very brief answer. -18.81. What is the difference between the Cost (as % of GNI) in Coal in 1972 and the Cost (as % of GNI) in Water in 1977?
Make the answer very short. -19.04. What is the difference between the Cost (as % of GNI) in Minerals in 1972 and the Cost (as % of GNI) in Energy in 1977?
Offer a very short reply. -19.52. What is the difference between the Cost (as % of GNI) in Minerals in 1972 and the Cost (as % of GNI) in Water in 1977?
Offer a very short reply. -19.75. What is the difference between the Cost (as % of GNI) of Energy in 1972 and the Cost (as % of GNI) of Water in 1977?
Your answer should be compact. -10.83. What is the difference between the Cost (as % of GNI) in Coal in 1972 and the Cost (as % of GNI) in Minerals in 1978?
Give a very brief answer. 0.71. What is the difference between the Cost (as % of GNI) of Coal in 1972 and the Cost (as % of GNI) of Energy in 1978?
Keep it short and to the point. -17.03. What is the difference between the Cost (as % of GNI) of Coal in 1972 and the Cost (as % of GNI) of Water in 1978?
Give a very brief answer. -17.23. What is the difference between the Cost (as % of GNI) in Minerals in 1972 and the Cost (as % of GNI) in Energy in 1978?
Provide a succinct answer. -17.74. What is the difference between the Cost (as % of GNI) in Minerals in 1972 and the Cost (as % of GNI) in Water in 1978?
Your response must be concise. -17.94. What is the difference between the Cost (as % of GNI) in Energy in 1972 and the Cost (as % of GNI) in Water in 1978?
Your answer should be compact. -9.02. What is the difference between the Cost (as % of GNI) of Coal in 1973 and the Cost (as % of GNI) of Minerals in 1974?
Your answer should be compact. 0.35. What is the difference between the Cost (as % of GNI) of Coal in 1973 and the Cost (as % of GNI) of Energy in 1974?
Keep it short and to the point. -26.01. What is the difference between the Cost (as % of GNI) in Coal in 1973 and the Cost (as % of GNI) in Water in 1974?
Make the answer very short. -26.55. What is the difference between the Cost (as % of GNI) in Minerals in 1973 and the Cost (as % of GNI) in Energy in 1974?
Give a very brief answer. -26.66. What is the difference between the Cost (as % of GNI) of Minerals in 1973 and the Cost (as % of GNI) of Water in 1974?
Provide a short and direct response. -27.2. What is the difference between the Cost (as % of GNI) of Energy in 1973 and the Cost (as % of GNI) of Water in 1974?
Offer a terse response. -15.05. What is the difference between the Cost (as % of GNI) in Coal in 1973 and the Cost (as % of GNI) in Minerals in 1975?
Keep it short and to the point. 0.41. What is the difference between the Cost (as % of GNI) of Coal in 1973 and the Cost (as % of GNI) of Energy in 1975?
Your response must be concise. -18.98. What is the difference between the Cost (as % of GNI) in Coal in 1973 and the Cost (as % of GNI) in Water in 1975?
Keep it short and to the point. -19.47. What is the difference between the Cost (as % of GNI) of Minerals in 1973 and the Cost (as % of GNI) of Energy in 1975?
Your answer should be compact. -19.63. What is the difference between the Cost (as % of GNI) in Minerals in 1973 and the Cost (as % of GNI) in Water in 1975?
Make the answer very short. -20.12. What is the difference between the Cost (as % of GNI) of Energy in 1973 and the Cost (as % of GNI) of Water in 1975?
Ensure brevity in your answer.  -7.97. What is the difference between the Cost (as % of GNI) of Coal in 1973 and the Cost (as % of GNI) of Minerals in 1976?
Make the answer very short. 0.62. What is the difference between the Cost (as % of GNI) in Coal in 1973 and the Cost (as % of GNI) in Energy in 1976?
Offer a terse response. -19.86. What is the difference between the Cost (as % of GNI) of Coal in 1973 and the Cost (as % of GNI) of Water in 1976?
Provide a succinct answer. -20.11. What is the difference between the Cost (as % of GNI) of Minerals in 1973 and the Cost (as % of GNI) of Energy in 1976?
Your answer should be compact. -20.51. What is the difference between the Cost (as % of GNI) of Minerals in 1973 and the Cost (as % of GNI) of Water in 1976?
Provide a short and direct response. -20.76. What is the difference between the Cost (as % of GNI) in Energy in 1973 and the Cost (as % of GNI) in Water in 1976?
Offer a very short reply. -8.6. What is the difference between the Cost (as % of GNI) of Coal in 1973 and the Cost (as % of GNI) of Minerals in 1977?
Provide a short and direct response. 0.65. What is the difference between the Cost (as % of GNI) in Coal in 1973 and the Cost (as % of GNI) in Energy in 1977?
Your response must be concise. -18.84. What is the difference between the Cost (as % of GNI) of Coal in 1973 and the Cost (as % of GNI) of Water in 1977?
Provide a succinct answer. -19.07. What is the difference between the Cost (as % of GNI) in Minerals in 1973 and the Cost (as % of GNI) in Energy in 1977?
Provide a succinct answer. -19.49. What is the difference between the Cost (as % of GNI) in Minerals in 1973 and the Cost (as % of GNI) in Water in 1977?
Provide a short and direct response. -19.72. What is the difference between the Cost (as % of GNI) of Energy in 1973 and the Cost (as % of GNI) of Water in 1977?
Your answer should be very brief. -7.57. What is the difference between the Cost (as % of GNI) in Coal in 1973 and the Cost (as % of GNI) in Minerals in 1978?
Ensure brevity in your answer.  0.68. What is the difference between the Cost (as % of GNI) of Coal in 1973 and the Cost (as % of GNI) of Energy in 1978?
Provide a succinct answer. -17.06. What is the difference between the Cost (as % of GNI) in Coal in 1973 and the Cost (as % of GNI) in Water in 1978?
Your answer should be compact. -17.26. What is the difference between the Cost (as % of GNI) in Minerals in 1973 and the Cost (as % of GNI) in Energy in 1978?
Make the answer very short. -17.71. What is the difference between the Cost (as % of GNI) in Minerals in 1973 and the Cost (as % of GNI) in Water in 1978?
Offer a very short reply. -17.91. What is the difference between the Cost (as % of GNI) of Energy in 1973 and the Cost (as % of GNI) of Water in 1978?
Ensure brevity in your answer.  -5.75. What is the difference between the Cost (as % of GNI) of Coal in 1974 and the Cost (as % of GNI) of Minerals in 1975?
Your answer should be compact. 0.13. What is the difference between the Cost (as % of GNI) in Coal in 1974 and the Cost (as % of GNI) in Energy in 1975?
Offer a very short reply. -19.26. What is the difference between the Cost (as % of GNI) of Coal in 1974 and the Cost (as % of GNI) of Water in 1975?
Offer a very short reply. -19.75. What is the difference between the Cost (as % of GNI) of Minerals in 1974 and the Cost (as % of GNI) of Energy in 1975?
Provide a short and direct response. -19.33. What is the difference between the Cost (as % of GNI) of Minerals in 1974 and the Cost (as % of GNI) of Water in 1975?
Your answer should be very brief. -19.82. What is the difference between the Cost (as % of GNI) in Energy in 1974 and the Cost (as % of GNI) in Water in 1975?
Your answer should be very brief. 6.54. What is the difference between the Cost (as % of GNI) in Coal in 1974 and the Cost (as % of GNI) in Minerals in 1976?
Make the answer very short. 0.34. What is the difference between the Cost (as % of GNI) in Coal in 1974 and the Cost (as % of GNI) in Energy in 1976?
Your response must be concise. -20.14. What is the difference between the Cost (as % of GNI) in Coal in 1974 and the Cost (as % of GNI) in Water in 1976?
Make the answer very short. -20.38. What is the difference between the Cost (as % of GNI) of Minerals in 1974 and the Cost (as % of GNI) of Energy in 1976?
Your answer should be compact. -20.21. What is the difference between the Cost (as % of GNI) in Minerals in 1974 and the Cost (as % of GNI) in Water in 1976?
Offer a very short reply. -20.45. What is the difference between the Cost (as % of GNI) in Energy in 1974 and the Cost (as % of GNI) in Water in 1976?
Provide a succinct answer. 5.91. What is the difference between the Cost (as % of GNI) in Coal in 1974 and the Cost (as % of GNI) in Minerals in 1977?
Ensure brevity in your answer.  0.38. What is the difference between the Cost (as % of GNI) in Coal in 1974 and the Cost (as % of GNI) in Energy in 1977?
Offer a very short reply. -19.12. What is the difference between the Cost (as % of GNI) of Coal in 1974 and the Cost (as % of GNI) of Water in 1977?
Provide a short and direct response. -19.35. What is the difference between the Cost (as % of GNI) of Minerals in 1974 and the Cost (as % of GNI) of Energy in 1977?
Your answer should be very brief. -19.19. What is the difference between the Cost (as % of GNI) of Minerals in 1974 and the Cost (as % of GNI) of Water in 1977?
Keep it short and to the point. -19.42. What is the difference between the Cost (as % of GNI) of Energy in 1974 and the Cost (as % of GNI) of Water in 1977?
Ensure brevity in your answer.  6.94. What is the difference between the Cost (as % of GNI) of Coal in 1974 and the Cost (as % of GNI) of Minerals in 1978?
Offer a terse response. 0.4. What is the difference between the Cost (as % of GNI) in Coal in 1974 and the Cost (as % of GNI) in Energy in 1978?
Provide a succinct answer. -17.33. What is the difference between the Cost (as % of GNI) in Coal in 1974 and the Cost (as % of GNI) in Water in 1978?
Offer a terse response. -17.53. What is the difference between the Cost (as % of GNI) of Minerals in 1974 and the Cost (as % of GNI) of Energy in 1978?
Your answer should be very brief. -17.4. What is the difference between the Cost (as % of GNI) of Minerals in 1974 and the Cost (as % of GNI) of Water in 1978?
Your answer should be compact. -17.6. What is the difference between the Cost (as % of GNI) of Energy in 1974 and the Cost (as % of GNI) of Water in 1978?
Give a very brief answer. 8.76. What is the difference between the Cost (as % of GNI) in Coal in 1975 and the Cost (as % of GNI) in Minerals in 1976?
Your answer should be compact. 0.33. What is the difference between the Cost (as % of GNI) of Coal in 1975 and the Cost (as % of GNI) of Energy in 1976?
Give a very brief answer. -20.15. What is the difference between the Cost (as % of GNI) of Coal in 1975 and the Cost (as % of GNI) of Water in 1976?
Give a very brief answer. -20.39. What is the difference between the Cost (as % of GNI) of Minerals in 1975 and the Cost (as % of GNI) of Energy in 1976?
Provide a succinct answer. -20.27. What is the difference between the Cost (as % of GNI) of Minerals in 1975 and the Cost (as % of GNI) of Water in 1976?
Ensure brevity in your answer.  -20.52. What is the difference between the Cost (as % of GNI) of Energy in 1975 and the Cost (as % of GNI) of Water in 1976?
Provide a succinct answer. -1.13. What is the difference between the Cost (as % of GNI) in Coal in 1975 and the Cost (as % of GNI) in Minerals in 1977?
Keep it short and to the point. 0.37. What is the difference between the Cost (as % of GNI) in Coal in 1975 and the Cost (as % of GNI) in Energy in 1977?
Your response must be concise. -19.13. What is the difference between the Cost (as % of GNI) in Coal in 1975 and the Cost (as % of GNI) in Water in 1977?
Keep it short and to the point. -19.36. What is the difference between the Cost (as % of GNI) in Minerals in 1975 and the Cost (as % of GNI) in Energy in 1977?
Your answer should be compact. -19.25. What is the difference between the Cost (as % of GNI) of Minerals in 1975 and the Cost (as % of GNI) of Water in 1977?
Your answer should be compact. -19.48. What is the difference between the Cost (as % of GNI) of Energy in 1975 and the Cost (as % of GNI) of Water in 1977?
Your response must be concise. -0.09. What is the difference between the Cost (as % of GNI) in Coal in 1975 and the Cost (as % of GNI) in Minerals in 1978?
Keep it short and to the point. 0.39. What is the difference between the Cost (as % of GNI) of Coal in 1975 and the Cost (as % of GNI) of Energy in 1978?
Make the answer very short. -17.35. What is the difference between the Cost (as % of GNI) in Coal in 1975 and the Cost (as % of GNI) in Water in 1978?
Give a very brief answer. -17.54. What is the difference between the Cost (as % of GNI) in Minerals in 1975 and the Cost (as % of GNI) in Energy in 1978?
Give a very brief answer. -17.47. What is the difference between the Cost (as % of GNI) of Minerals in 1975 and the Cost (as % of GNI) of Water in 1978?
Your answer should be very brief. -17.67. What is the difference between the Cost (as % of GNI) of Energy in 1975 and the Cost (as % of GNI) of Water in 1978?
Make the answer very short. 1.72. What is the difference between the Cost (as % of GNI) of Coal in 1976 and the Cost (as % of GNI) of Minerals in 1977?
Make the answer very short. 0.36. What is the difference between the Cost (as % of GNI) of Coal in 1976 and the Cost (as % of GNI) of Energy in 1977?
Make the answer very short. -19.13. What is the difference between the Cost (as % of GNI) in Coal in 1976 and the Cost (as % of GNI) in Water in 1977?
Provide a succinct answer. -19.37. What is the difference between the Cost (as % of GNI) of Minerals in 1976 and the Cost (as % of GNI) of Energy in 1977?
Offer a very short reply. -19.46. What is the difference between the Cost (as % of GNI) in Minerals in 1976 and the Cost (as % of GNI) in Water in 1977?
Provide a short and direct response. -19.69. What is the difference between the Cost (as % of GNI) of Energy in 1976 and the Cost (as % of GNI) of Water in 1977?
Offer a very short reply. 0.79. What is the difference between the Cost (as % of GNI) in Coal in 1976 and the Cost (as % of GNI) in Minerals in 1978?
Make the answer very short. 0.38. What is the difference between the Cost (as % of GNI) in Coal in 1976 and the Cost (as % of GNI) in Energy in 1978?
Give a very brief answer. -17.35. What is the difference between the Cost (as % of GNI) of Coal in 1976 and the Cost (as % of GNI) of Water in 1978?
Offer a terse response. -17.55. What is the difference between the Cost (as % of GNI) in Minerals in 1976 and the Cost (as % of GNI) in Energy in 1978?
Your response must be concise. -17.67. What is the difference between the Cost (as % of GNI) in Minerals in 1976 and the Cost (as % of GNI) in Water in 1978?
Your answer should be very brief. -17.87. What is the difference between the Cost (as % of GNI) in Energy in 1976 and the Cost (as % of GNI) in Water in 1978?
Make the answer very short. 2.61. What is the difference between the Cost (as % of GNI) of Coal in 1977 and the Cost (as % of GNI) of Minerals in 1978?
Your response must be concise. 0.39. What is the difference between the Cost (as % of GNI) in Coal in 1977 and the Cost (as % of GNI) in Energy in 1978?
Offer a terse response. -17.35. What is the difference between the Cost (as % of GNI) of Coal in 1977 and the Cost (as % of GNI) of Water in 1978?
Offer a terse response. -17.55. What is the difference between the Cost (as % of GNI) in Minerals in 1977 and the Cost (as % of GNI) in Energy in 1978?
Provide a short and direct response. -17.71. What is the difference between the Cost (as % of GNI) in Minerals in 1977 and the Cost (as % of GNI) in Water in 1978?
Provide a short and direct response. -17.91. What is the difference between the Cost (as % of GNI) in Energy in 1977 and the Cost (as % of GNI) in Water in 1978?
Keep it short and to the point. 1.58. What is the average Cost (as % of GNI) of Coal per year?
Offer a very short reply. 0.57. What is the average Cost (as % of GNI) in Minerals per year?
Offer a very short reply. 0.11. What is the average Cost (as % of GNI) of Energy per year?
Your answer should be very brief. 15.64. What is the average Cost (as % of GNI) of Water per year?
Offer a very short reply. 15.94. In the year 1970, what is the difference between the Cost (as % of GNI) in Coal and Cost (as % of GNI) in Minerals?
Your answer should be very brief. 0.7. In the year 1970, what is the difference between the Cost (as % of GNI) in Coal and Cost (as % of GNI) in Energy?
Ensure brevity in your answer.  -5.68. In the year 1970, what is the difference between the Cost (as % of GNI) in Coal and Cost (as % of GNI) in Water?
Ensure brevity in your answer.  -5.97. In the year 1970, what is the difference between the Cost (as % of GNI) in Minerals and Cost (as % of GNI) in Energy?
Your answer should be very brief. -6.38. In the year 1970, what is the difference between the Cost (as % of GNI) of Minerals and Cost (as % of GNI) of Water?
Your answer should be very brief. -6.67. In the year 1970, what is the difference between the Cost (as % of GNI) of Energy and Cost (as % of GNI) of Water?
Offer a terse response. -0.29. In the year 1971, what is the difference between the Cost (as % of GNI) in Coal and Cost (as % of GNI) in Minerals?
Provide a short and direct response. 0.75. In the year 1971, what is the difference between the Cost (as % of GNI) of Coal and Cost (as % of GNI) of Energy?
Your answer should be compact. -8.06. In the year 1971, what is the difference between the Cost (as % of GNI) of Coal and Cost (as % of GNI) of Water?
Your answer should be very brief. -8.3. In the year 1971, what is the difference between the Cost (as % of GNI) of Minerals and Cost (as % of GNI) of Energy?
Offer a terse response. -8.81. In the year 1971, what is the difference between the Cost (as % of GNI) of Minerals and Cost (as % of GNI) of Water?
Give a very brief answer. -9.05. In the year 1971, what is the difference between the Cost (as % of GNI) of Energy and Cost (as % of GNI) of Water?
Your answer should be compact. -0.24. In the year 1972, what is the difference between the Cost (as % of GNI) in Coal and Cost (as % of GNI) in Minerals?
Ensure brevity in your answer.  0.71. In the year 1972, what is the difference between the Cost (as % of GNI) in Coal and Cost (as % of GNI) in Energy?
Ensure brevity in your answer.  -8.21. In the year 1972, what is the difference between the Cost (as % of GNI) in Coal and Cost (as % of GNI) in Water?
Provide a short and direct response. -8.44. In the year 1972, what is the difference between the Cost (as % of GNI) in Minerals and Cost (as % of GNI) in Energy?
Offer a terse response. -8.92. In the year 1972, what is the difference between the Cost (as % of GNI) in Minerals and Cost (as % of GNI) in Water?
Your answer should be very brief. -9.16. In the year 1972, what is the difference between the Cost (as % of GNI) in Energy and Cost (as % of GNI) in Water?
Make the answer very short. -0.23. In the year 1973, what is the difference between the Cost (as % of GNI) in Coal and Cost (as % of GNI) in Minerals?
Your response must be concise. 0.65. In the year 1973, what is the difference between the Cost (as % of GNI) of Coal and Cost (as % of GNI) of Energy?
Your answer should be very brief. -11.5. In the year 1973, what is the difference between the Cost (as % of GNI) in Coal and Cost (as % of GNI) in Water?
Your answer should be compact. -11.8. In the year 1973, what is the difference between the Cost (as % of GNI) of Minerals and Cost (as % of GNI) of Energy?
Provide a short and direct response. -12.15. In the year 1973, what is the difference between the Cost (as % of GNI) in Minerals and Cost (as % of GNI) in Water?
Your answer should be compact. -12.45. In the year 1973, what is the difference between the Cost (as % of GNI) in Energy and Cost (as % of GNI) in Water?
Provide a short and direct response. -0.29. In the year 1974, what is the difference between the Cost (as % of GNI) in Coal and Cost (as % of GNI) in Minerals?
Provide a short and direct response. 0.07. In the year 1974, what is the difference between the Cost (as % of GNI) of Coal and Cost (as % of GNI) of Energy?
Offer a terse response. -26.29. In the year 1974, what is the difference between the Cost (as % of GNI) of Coal and Cost (as % of GNI) of Water?
Provide a short and direct response. -26.83. In the year 1974, what is the difference between the Cost (as % of GNI) in Minerals and Cost (as % of GNI) in Energy?
Offer a terse response. -26.36. In the year 1974, what is the difference between the Cost (as % of GNI) of Minerals and Cost (as % of GNI) of Water?
Provide a short and direct response. -26.9. In the year 1974, what is the difference between the Cost (as % of GNI) of Energy and Cost (as % of GNI) of Water?
Your answer should be very brief. -0.54. In the year 1975, what is the difference between the Cost (as % of GNI) in Coal and Cost (as % of GNI) in Minerals?
Ensure brevity in your answer.  0.12. In the year 1975, what is the difference between the Cost (as % of GNI) of Coal and Cost (as % of GNI) of Energy?
Offer a very short reply. -19.27. In the year 1975, what is the difference between the Cost (as % of GNI) of Coal and Cost (as % of GNI) of Water?
Provide a short and direct response. -19.76. In the year 1975, what is the difference between the Cost (as % of GNI) of Minerals and Cost (as % of GNI) of Energy?
Give a very brief answer. -19.39. In the year 1975, what is the difference between the Cost (as % of GNI) in Minerals and Cost (as % of GNI) in Water?
Make the answer very short. -19.88. In the year 1975, what is the difference between the Cost (as % of GNI) of Energy and Cost (as % of GNI) of Water?
Keep it short and to the point. -0.49. In the year 1976, what is the difference between the Cost (as % of GNI) in Coal and Cost (as % of GNI) in Minerals?
Offer a terse response. 0.32. In the year 1976, what is the difference between the Cost (as % of GNI) of Coal and Cost (as % of GNI) of Energy?
Offer a terse response. -20.16. In the year 1976, what is the difference between the Cost (as % of GNI) in Coal and Cost (as % of GNI) in Water?
Ensure brevity in your answer.  -20.4. In the year 1976, what is the difference between the Cost (as % of GNI) of Minerals and Cost (as % of GNI) of Energy?
Your response must be concise. -20.48. In the year 1976, what is the difference between the Cost (as % of GNI) of Minerals and Cost (as % of GNI) of Water?
Give a very brief answer. -20.72. In the year 1976, what is the difference between the Cost (as % of GNI) of Energy and Cost (as % of GNI) of Water?
Your answer should be very brief. -0.24. In the year 1977, what is the difference between the Cost (as % of GNI) of Coal and Cost (as % of GNI) of Minerals?
Make the answer very short. 0.36. In the year 1977, what is the difference between the Cost (as % of GNI) of Coal and Cost (as % of GNI) of Energy?
Ensure brevity in your answer.  -19.13. In the year 1977, what is the difference between the Cost (as % of GNI) in Coal and Cost (as % of GNI) in Water?
Ensure brevity in your answer.  -19.36. In the year 1977, what is the difference between the Cost (as % of GNI) of Minerals and Cost (as % of GNI) of Energy?
Ensure brevity in your answer.  -19.49. In the year 1977, what is the difference between the Cost (as % of GNI) in Minerals and Cost (as % of GNI) in Water?
Keep it short and to the point. -19.72. In the year 1977, what is the difference between the Cost (as % of GNI) of Energy and Cost (as % of GNI) of Water?
Make the answer very short. -0.23. In the year 1978, what is the difference between the Cost (as % of GNI) of Coal and Cost (as % of GNI) of Minerals?
Your answer should be very brief. 0.42. In the year 1978, what is the difference between the Cost (as % of GNI) of Coal and Cost (as % of GNI) of Energy?
Provide a short and direct response. -17.32. In the year 1978, what is the difference between the Cost (as % of GNI) in Coal and Cost (as % of GNI) in Water?
Your response must be concise. -17.52. In the year 1978, what is the difference between the Cost (as % of GNI) in Minerals and Cost (as % of GNI) in Energy?
Keep it short and to the point. -17.74. In the year 1978, what is the difference between the Cost (as % of GNI) of Minerals and Cost (as % of GNI) of Water?
Keep it short and to the point. -17.94. In the year 1978, what is the difference between the Cost (as % of GNI) in Energy and Cost (as % of GNI) in Water?
Your answer should be very brief. -0.2. What is the ratio of the Cost (as % of GNI) of Coal in 1970 to that in 1971?
Make the answer very short. 0.96. What is the ratio of the Cost (as % of GNI) in Minerals in 1970 to that in 1971?
Give a very brief answer. 1.63. What is the ratio of the Cost (as % of GNI) of Energy in 1970 to that in 1971?
Provide a succinct answer. 0.73. What is the ratio of the Cost (as % of GNI) of Water in 1970 to that in 1971?
Keep it short and to the point. 0.74. What is the ratio of the Cost (as % of GNI) in Coal in 1970 to that in 1972?
Your response must be concise. 1.02. What is the ratio of the Cost (as % of GNI) of Minerals in 1970 to that in 1972?
Offer a terse response. 2.26. What is the ratio of the Cost (as % of GNI) in Energy in 1970 to that in 1972?
Give a very brief answer. 0.72. What is the ratio of the Cost (as % of GNI) of Water in 1970 to that in 1972?
Your response must be concise. 0.73. What is the ratio of the Cost (as % of GNI) in Coal in 1970 to that in 1973?
Your answer should be very brief. 1.06. What is the ratio of the Cost (as % of GNI) in Minerals in 1970 to that in 1973?
Make the answer very short. 0.94. What is the ratio of the Cost (as % of GNI) in Energy in 1970 to that in 1973?
Your answer should be compact. 0.53. What is the ratio of the Cost (as % of GNI) in Water in 1970 to that in 1973?
Provide a succinct answer. 0.54. What is the ratio of the Cost (as % of GNI) of Coal in 1970 to that in 1974?
Provide a short and direct response. 1.74. What is the ratio of the Cost (as % of GNI) of Minerals in 1970 to that in 1974?
Your answer should be compact. 0.15. What is the ratio of the Cost (as % of GNI) in Energy in 1970 to that in 1974?
Provide a succinct answer. 0.24. What is the ratio of the Cost (as % of GNI) of Water in 1970 to that in 1974?
Offer a terse response. 0.25. What is the ratio of the Cost (as % of GNI) in Coal in 1970 to that in 1975?
Your response must be concise. 1.79. What is the ratio of the Cost (as % of GNI) in Minerals in 1970 to that in 1975?
Offer a terse response. 0.18. What is the ratio of the Cost (as % of GNI) in Energy in 1970 to that in 1975?
Keep it short and to the point. 0.33. What is the ratio of the Cost (as % of GNI) of Water in 1970 to that in 1975?
Your answer should be very brief. 0.33. What is the ratio of the Cost (as % of GNI) of Coal in 1970 to that in 1976?
Your response must be concise. 1.82. What is the ratio of the Cost (as % of GNI) of Minerals in 1970 to that in 1976?
Provide a succinct answer. 0.59. What is the ratio of the Cost (as % of GNI) of Energy in 1970 to that in 1976?
Keep it short and to the point. 0.31. What is the ratio of the Cost (as % of GNI) in Water in 1970 to that in 1976?
Offer a very short reply. 0.32. What is the ratio of the Cost (as % of GNI) in Coal in 1970 to that in 1977?
Offer a terse response. 1.8. What is the ratio of the Cost (as % of GNI) of Energy in 1970 to that in 1977?
Ensure brevity in your answer.  0.33. What is the ratio of the Cost (as % of GNI) in Water in 1970 to that in 1977?
Offer a terse response. 0.34. What is the ratio of the Cost (as % of GNI) of Coal in 1970 to that in 1978?
Your response must be concise. 1.68. What is the ratio of the Cost (as % of GNI) of Minerals in 1970 to that in 1978?
Make the answer very short. 1.86. What is the ratio of the Cost (as % of GNI) in Energy in 1970 to that in 1978?
Your response must be concise. 0.36. What is the ratio of the Cost (as % of GNI) in Water in 1970 to that in 1978?
Provide a succinct answer. 0.37. What is the ratio of the Cost (as % of GNI) of Coal in 1971 to that in 1972?
Keep it short and to the point. 1.06. What is the ratio of the Cost (as % of GNI) of Minerals in 1971 to that in 1972?
Give a very brief answer. 1.39. What is the ratio of the Cost (as % of GNI) in Energy in 1971 to that in 1972?
Give a very brief answer. 0.99. What is the ratio of the Cost (as % of GNI) of Coal in 1971 to that in 1973?
Your response must be concise. 1.11. What is the ratio of the Cost (as % of GNI) in Minerals in 1971 to that in 1973?
Your answer should be very brief. 0.58. What is the ratio of the Cost (as % of GNI) in Energy in 1971 to that in 1973?
Offer a terse response. 0.72. What is the ratio of the Cost (as % of GNI) of Water in 1971 to that in 1973?
Make the answer very short. 0.73. What is the ratio of the Cost (as % of GNI) of Coal in 1971 to that in 1974?
Provide a succinct answer. 1.81. What is the ratio of the Cost (as % of GNI) in Minerals in 1971 to that in 1974?
Your response must be concise. 0.09. What is the ratio of the Cost (as % of GNI) of Energy in 1971 to that in 1974?
Ensure brevity in your answer.  0.33. What is the ratio of the Cost (as % of GNI) in Coal in 1971 to that in 1975?
Offer a very short reply. 1.86. What is the ratio of the Cost (as % of GNI) of Minerals in 1971 to that in 1975?
Provide a short and direct response. 0.11. What is the ratio of the Cost (as % of GNI) in Energy in 1971 to that in 1975?
Keep it short and to the point. 0.45. What is the ratio of the Cost (as % of GNI) of Water in 1971 to that in 1975?
Your answer should be very brief. 0.45. What is the ratio of the Cost (as % of GNI) in Coal in 1971 to that in 1976?
Your answer should be compact. 1.89. What is the ratio of the Cost (as % of GNI) of Minerals in 1971 to that in 1976?
Give a very brief answer. 0.36. What is the ratio of the Cost (as % of GNI) of Energy in 1971 to that in 1976?
Your response must be concise. 0.43. What is the ratio of the Cost (as % of GNI) of Water in 1971 to that in 1976?
Your answer should be compact. 0.44. What is the ratio of the Cost (as % of GNI) of Coal in 1971 to that in 1977?
Provide a short and direct response. 1.88. What is the ratio of the Cost (as % of GNI) of Minerals in 1971 to that in 1977?
Provide a succinct answer. 0.61. What is the ratio of the Cost (as % of GNI) in Energy in 1971 to that in 1977?
Ensure brevity in your answer.  0.45. What is the ratio of the Cost (as % of GNI) of Water in 1971 to that in 1977?
Offer a very short reply. 0.46. What is the ratio of the Cost (as % of GNI) of Coal in 1971 to that in 1978?
Ensure brevity in your answer.  1.75. What is the ratio of the Cost (as % of GNI) of Minerals in 1971 to that in 1978?
Provide a short and direct response. 1.14. What is the ratio of the Cost (as % of GNI) of Energy in 1971 to that in 1978?
Offer a terse response. 0.5. What is the ratio of the Cost (as % of GNI) of Water in 1971 to that in 1978?
Provide a succinct answer. 0.51. What is the ratio of the Cost (as % of GNI) of Coal in 1972 to that in 1973?
Offer a terse response. 1.04. What is the ratio of the Cost (as % of GNI) in Minerals in 1972 to that in 1973?
Offer a terse response. 0.42. What is the ratio of the Cost (as % of GNI) in Energy in 1972 to that in 1973?
Your response must be concise. 0.73. What is the ratio of the Cost (as % of GNI) in Water in 1972 to that in 1973?
Make the answer very short. 0.73. What is the ratio of the Cost (as % of GNI) of Coal in 1972 to that in 1974?
Your answer should be very brief. 1.71. What is the ratio of the Cost (as % of GNI) in Minerals in 1972 to that in 1974?
Offer a very short reply. 0.07. What is the ratio of the Cost (as % of GNI) of Energy in 1972 to that in 1974?
Your answer should be very brief. 0.33. What is the ratio of the Cost (as % of GNI) in Water in 1972 to that in 1974?
Offer a very short reply. 0.34. What is the ratio of the Cost (as % of GNI) of Coal in 1972 to that in 1975?
Ensure brevity in your answer.  1.76. What is the ratio of the Cost (as % of GNI) of Minerals in 1972 to that in 1975?
Keep it short and to the point. 0.08. What is the ratio of the Cost (as % of GNI) in Energy in 1972 to that in 1975?
Make the answer very short. 0.45. What is the ratio of the Cost (as % of GNI) of Water in 1972 to that in 1975?
Offer a terse response. 0.46. What is the ratio of the Cost (as % of GNI) in Coal in 1972 to that in 1976?
Give a very brief answer. 1.79. What is the ratio of the Cost (as % of GNI) of Minerals in 1972 to that in 1976?
Offer a very short reply. 0.26. What is the ratio of the Cost (as % of GNI) of Energy in 1972 to that in 1976?
Make the answer very short. 0.43. What is the ratio of the Cost (as % of GNI) of Water in 1972 to that in 1976?
Keep it short and to the point. 0.44. What is the ratio of the Cost (as % of GNI) of Coal in 1972 to that in 1977?
Make the answer very short. 1.77. What is the ratio of the Cost (as % of GNI) in Minerals in 1972 to that in 1977?
Give a very brief answer. 0.44. What is the ratio of the Cost (as % of GNI) of Energy in 1972 to that in 1977?
Keep it short and to the point. 0.46. What is the ratio of the Cost (as % of GNI) in Water in 1972 to that in 1977?
Your answer should be compact. 0.46. What is the ratio of the Cost (as % of GNI) of Coal in 1972 to that in 1978?
Ensure brevity in your answer.  1.65. What is the ratio of the Cost (as % of GNI) of Minerals in 1972 to that in 1978?
Offer a very short reply. 0.82. What is the ratio of the Cost (as % of GNI) of Energy in 1972 to that in 1978?
Give a very brief answer. 0.5. What is the ratio of the Cost (as % of GNI) in Water in 1972 to that in 1978?
Offer a terse response. 0.51. What is the ratio of the Cost (as % of GNI) of Coal in 1973 to that in 1974?
Your answer should be compact. 1.64. What is the ratio of the Cost (as % of GNI) of Minerals in 1973 to that in 1974?
Your answer should be compact. 0.16. What is the ratio of the Cost (as % of GNI) of Energy in 1973 to that in 1974?
Your answer should be very brief. 0.46. What is the ratio of the Cost (as % of GNI) in Water in 1973 to that in 1974?
Provide a short and direct response. 0.46. What is the ratio of the Cost (as % of GNI) of Coal in 1973 to that in 1975?
Offer a terse response. 1.69. What is the ratio of the Cost (as % of GNI) of Minerals in 1973 to that in 1975?
Provide a short and direct response. 0.19. What is the ratio of the Cost (as % of GNI) of Energy in 1973 to that in 1975?
Provide a short and direct response. 0.62. What is the ratio of the Cost (as % of GNI) in Water in 1973 to that in 1975?
Give a very brief answer. 0.62. What is the ratio of the Cost (as % of GNI) of Coal in 1973 to that in 1976?
Give a very brief answer. 1.71. What is the ratio of the Cost (as % of GNI) in Minerals in 1973 to that in 1976?
Keep it short and to the point. 0.63. What is the ratio of the Cost (as % of GNI) of Energy in 1973 to that in 1976?
Offer a terse response. 0.59. What is the ratio of the Cost (as % of GNI) in Water in 1973 to that in 1976?
Make the answer very short. 0.6. What is the ratio of the Cost (as % of GNI) in Coal in 1973 to that in 1977?
Offer a terse response. 1.7. What is the ratio of the Cost (as % of GNI) of Minerals in 1973 to that in 1977?
Provide a short and direct response. 1.06. What is the ratio of the Cost (as % of GNI) of Energy in 1973 to that in 1977?
Your answer should be compact. 0.62. What is the ratio of the Cost (as % of GNI) of Water in 1973 to that in 1977?
Offer a terse response. 0.63. What is the ratio of the Cost (as % of GNI) in Coal in 1973 to that in 1978?
Keep it short and to the point. 1.58. What is the ratio of the Cost (as % of GNI) in Minerals in 1973 to that in 1978?
Your answer should be very brief. 1.97. What is the ratio of the Cost (as % of GNI) of Energy in 1973 to that in 1978?
Offer a very short reply. 0.69. What is the ratio of the Cost (as % of GNI) in Water in 1973 to that in 1978?
Your answer should be very brief. 0.7. What is the ratio of the Cost (as % of GNI) in Coal in 1974 to that in 1975?
Ensure brevity in your answer.  1.03. What is the ratio of the Cost (as % of GNI) in Minerals in 1974 to that in 1975?
Offer a very short reply. 1.21. What is the ratio of the Cost (as % of GNI) in Energy in 1974 to that in 1975?
Provide a succinct answer. 1.36. What is the ratio of the Cost (as % of GNI) in Water in 1974 to that in 1975?
Offer a terse response. 1.35. What is the ratio of the Cost (as % of GNI) of Coal in 1974 to that in 1976?
Provide a short and direct response. 1.04. What is the ratio of the Cost (as % of GNI) in Minerals in 1974 to that in 1976?
Give a very brief answer. 3.94. What is the ratio of the Cost (as % of GNI) of Energy in 1974 to that in 1976?
Offer a terse response. 1.3. What is the ratio of the Cost (as % of GNI) of Water in 1974 to that in 1976?
Your answer should be compact. 1.31. What is the ratio of the Cost (as % of GNI) in Coal in 1974 to that in 1977?
Keep it short and to the point. 1.04. What is the ratio of the Cost (as % of GNI) in Minerals in 1974 to that in 1977?
Provide a succinct answer. 6.64. What is the ratio of the Cost (as % of GNI) of Energy in 1974 to that in 1977?
Offer a very short reply. 1.37. What is the ratio of the Cost (as % of GNI) of Water in 1974 to that in 1977?
Give a very brief answer. 1.38. What is the ratio of the Cost (as % of GNI) in Coal in 1974 to that in 1978?
Your response must be concise. 0.96. What is the ratio of the Cost (as % of GNI) of Minerals in 1974 to that in 1978?
Your answer should be compact. 12.38. What is the ratio of the Cost (as % of GNI) of Energy in 1974 to that in 1978?
Make the answer very short. 1.5. What is the ratio of the Cost (as % of GNI) in Water in 1974 to that in 1978?
Your answer should be compact. 1.52. What is the ratio of the Cost (as % of GNI) in Coal in 1975 to that in 1976?
Ensure brevity in your answer.  1.02. What is the ratio of the Cost (as % of GNI) of Minerals in 1975 to that in 1976?
Ensure brevity in your answer.  3.25. What is the ratio of the Cost (as % of GNI) of Energy in 1975 to that in 1976?
Provide a short and direct response. 0.96. What is the ratio of the Cost (as % of GNI) of Water in 1975 to that in 1976?
Keep it short and to the point. 0.97. What is the ratio of the Cost (as % of GNI) of Coal in 1975 to that in 1977?
Offer a very short reply. 1.01. What is the ratio of the Cost (as % of GNI) in Minerals in 1975 to that in 1977?
Offer a very short reply. 5.48. What is the ratio of the Cost (as % of GNI) in Water in 1975 to that in 1977?
Your answer should be very brief. 1.02. What is the ratio of the Cost (as % of GNI) of Coal in 1975 to that in 1978?
Your answer should be compact. 0.94. What is the ratio of the Cost (as % of GNI) of Minerals in 1975 to that in 1978?
Your answer should be compact. 10.21. What is the ratio of the Cost (as % of GNI) of Energy in 1975 to that in 1978?
Give a very brief answer. 1.11. What is the ratio of the Cost (as % of GNI) in Water in 1975 to that in 1978?
Your response must be concise. 1.12. What is the ratio of the Cost (as % of GNI) of Coal in 1976 to that in 1977?
Offer a very short reply. 0.99. What is the ratio of the Cost (as % of GNI) of Minerals in 1976 to that in 1977?
Give a very brief answer. 1.69. What is the ratio of the Cost (as % of GNI) in Energy in 1976 to that in 1977?
Give a very brief answer. 1.05. What is the ratio of the Cost (as % of GNI) of Water in 1976 to that in 1977?
Provide a succinct answer. 1.05. What is the ratio of the Cost (as % of GNI) of Coal in 1976 to that in 1978?
Keep it short and to the point. 0.92. What is the ratio of the Cost (as % of GNI) of Minerals in 1976 to that in 1978?
Your answer should be compact. 3.14. What is the ratio of the Cost (as % of GNI) of Energy in 1976 to that in 1978?
Make the answer very short. 1.16. What is the ratio of the Cost (as % of GNI) in Water in 1976 to that in 1978?
Give a very brief answer. 1.16. What is the ratio of the Cost (as % of GNI) of Coal in 1977 to that in 1978?
Keep it short and to the point. 0.93. What is the ratio of the Cost (as % of GNI) in Minerals in 1977 to that in 1978?
Ensure brevity in your answer.  1.86. What is the ratio of the Cost (as % of GNI) of Energy in 1977 to that in 1978?
Provide a succinct answer. 1.1. What is the ratio of the Cost (as % of GNI) of Water in 1977 to that in 1978?
Keep it short and to the point. 1.1. What is the difference between the highest and the second highest Cost (as % of GNI) of Coal?
Your answer should be compact. 0.03. What is the difference between the highest and the second highest Cost (as % of GNI) in Minerals?
Provide a succinct answer. 0.06. What is the difference between the highest and the second highest Cost (as % of GNI) of Energy?
Make the answer very short. 6.15. What is the difference between the highest and the second highest Cost (as % of GNI) in Water?
Ensure brevity in your answer.  6.45. What is the difference between the highest and the lowest Cost (as % of GNI) of Coal?
Make the answer very short. 0.37. What is the difference between the highest and the lowest Cost (as % of GNI) in Minerals?
Give a very brief answer. 0.34. What is the difference between the highest and the lowest Cost (as % of GNI) of Energy?
Make the answer very short. 20.29. What is the difference between the highest and the lowest Cost (as % of GNI) in Water?
Your response must be concise. 20.54. 